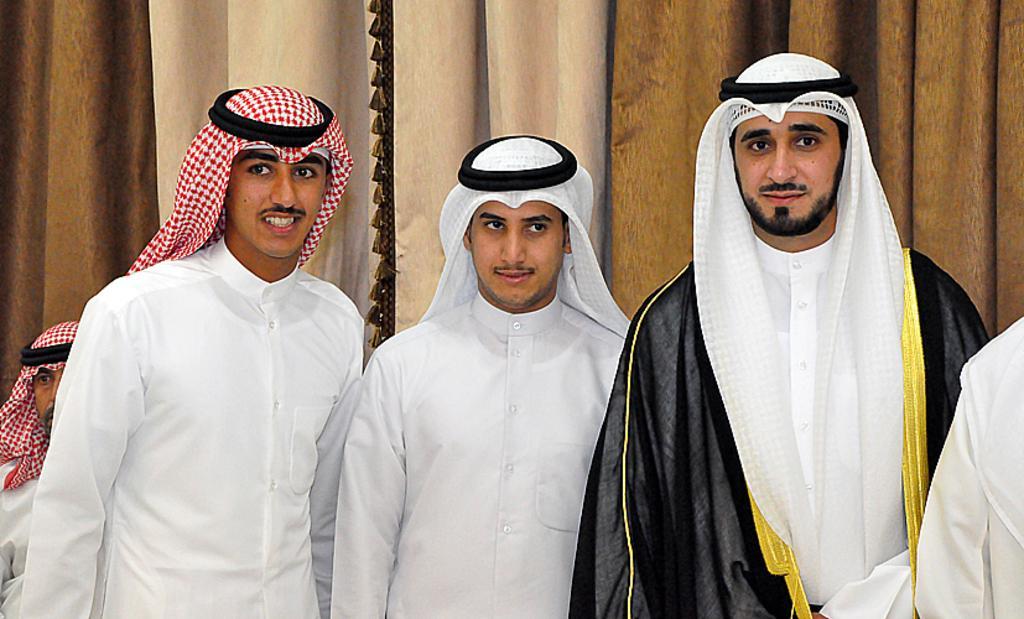Describe this image in one or two sentences. In this image we can see a few people, behind them we can see the curtains. 